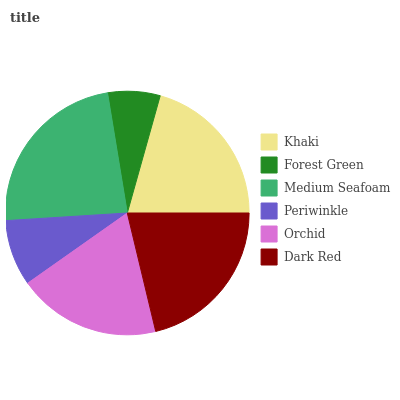Is Forest Green the minimum?
Answer yes or no. Yes. Is Medium Seafoam the maximum?
Answer yes or no. Yes. Is Medium Seafoam the minimum?
Answer yes or no. No. Is Forest Green the maximum?
Answer yes or no. No. Is Medium Seafoam greater than Forest Green?
Answer yes or no. Yes. Is Forest Green less than Medium Seafoam?
Answer yes or no. Yes. Is Forest Green greater than Medium Seafoam?
Answer yes or no. No. Is Medium Seafoam less than Forest Green?
Answer yes or no. No. Is Khaki the high median?
Answer yes or no. Yes. Is Orchid the low median?
Answer yes or no. Yes. Is Orchid the high median?
Answer yes or no. No. Is Khaki the low median?
Answer yes or no. No. 